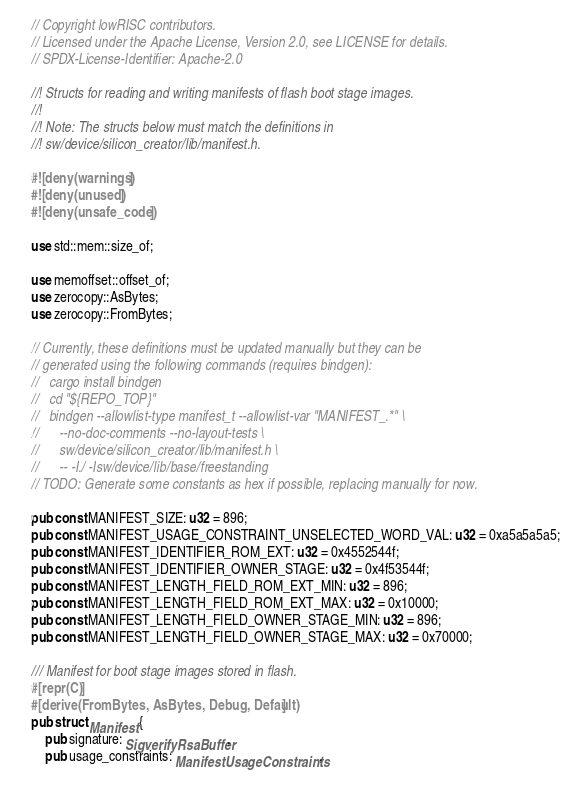<code> <loc_0><loc_0><loc_500><loc_500><_Rust_>// Copyright lowRISC contributors.
// Licensed under the Apache License, Version 2.0, see LICENSE for details.
// SPDX-License-Identifier: Apache-2.0

//! Structs for reading and writing manifests of flash boot stage images.
//!
//! Note: The structs below must match the definitions in
//! sw/device/silicon_creator/lib/manifest.h.

#![deny(warnings)]
#![deny(unused)]
#![deny(unsafe_code)]

use std::mem::size_of;

use memoffset::offset_of;
use zerocopy::AsBytes;
use zerocopy::FromBytes;

// Currently, these definitions must be updated manually but they can be
// generated using the following commands (requires bindgen):
//   cargo install bindgen
//   cd "${REPO_TOP}"
//   bindgen --allowlist-type manifest_t --allowlist-var "MANIFEST_.*" \
//      --no-doc-comments --no-layout-tests \
//      sw/device/silicon_creator/lib/manifest.h \
//      -- -I./ -Isw/device/lib/base/freestanding
// TODO: Generate some constants as hex if possible, replacing manually for now.

pub const MANIFEST_SIZE: u32 = 896;
pub const MANIFEST_USAGE_CONSTRAINT_UNSELECTED_WORD_VAL: u32 = 0xa5a5a5a5;
pub const MANIFEST_IDENTIFIER_ROM_EXT: u32 = 0x4552544f;
pub const MANIFEST_IDENTIFIER_OWNER_STAGE: u32 = 0x4f53544f;
pub const MANIFEST_LENGTH_FIELD_ROM_EXT_MIN: u32 = 896;
pub const MANIFEST_LENGTH_FIELD_ROM_EXT_MAX: u32 = 0x10000;
pub const MANIFEST_LENGTH_FIELD_OWNER_STAGE_MIN: u32 = 896;
pub const MANIFEST_LENGTH_FIELD_OWNER_STAGE_MAX: u32 = 0x70000;

/// Manifest for boot stage images stored in flash.
#[repr(C)]
#[derive(FromBytes, AsBytes, Debug, Default)]
pub struct Manifest {
    pub signature: SigverifyRsaBuffer,
    pub usage_constraints: ManifestUsageConstraints,</code> 